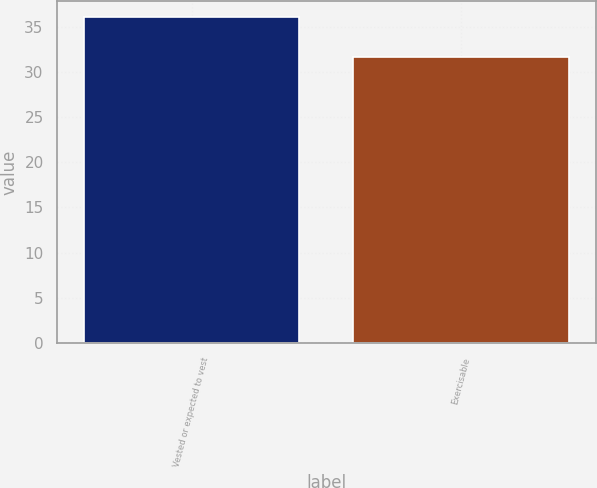<chart> <loc_0><loc_0><loc_500><loc_500><bar_chart><fcel>Vested or expected to vest<fcel>Exercisable<nl><fcel>36.05<fcel>31.61<nl></chart> 